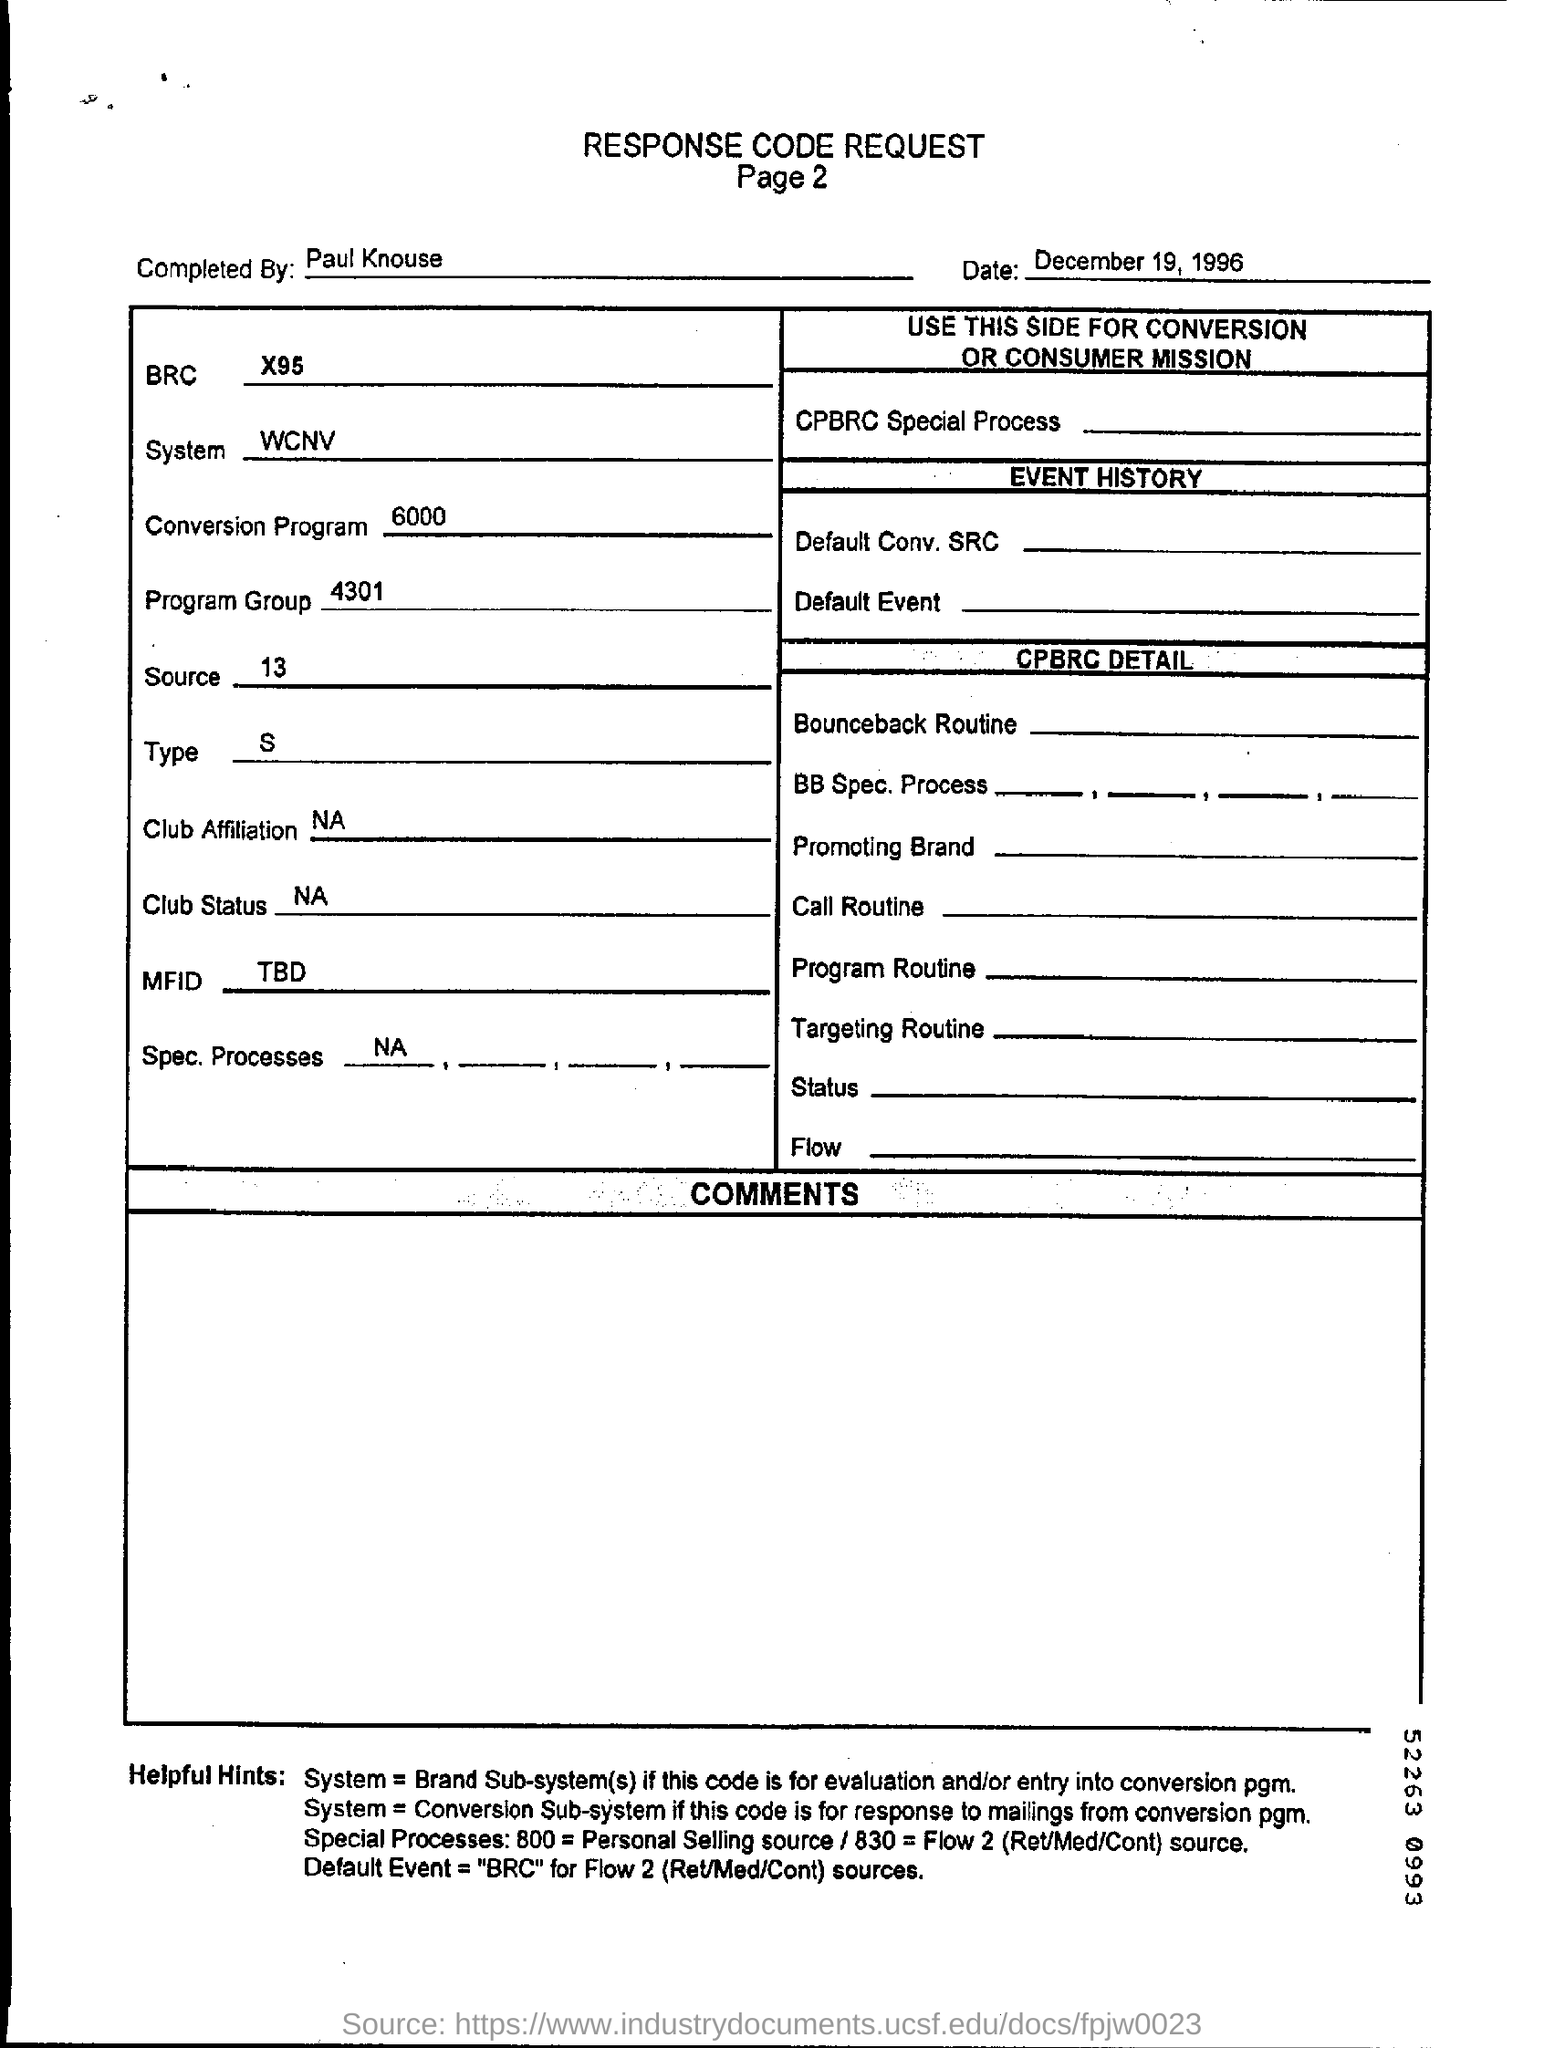List a handful of essential elements in this visual. The document is completed by Paul Knouse. The source number mentioned is 13. The BRC code mentioned is X95. The date mentioned in the form is December 19, 1996. 